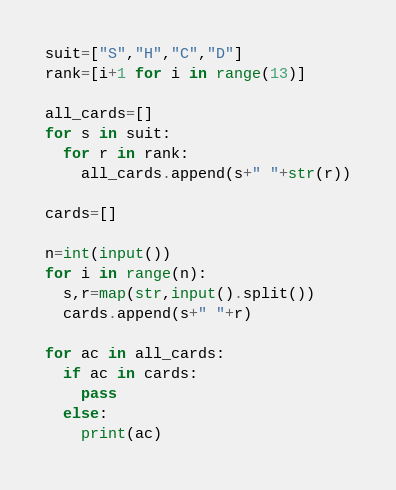Convert code to text. <code><loc_0><loc_0><loc_500><loc_500><_Python_>suit=["S","H","C","D"]
rank=[i+1 for i in range(13)]

all_cards=[]
for s in suit:
  for r in rank:
    all_cards.append(s+" "+str(r))

cards=[]

n=int(input())
for i in range(n):
  s,r=map(str,input().split())
  cards.append(s+" "+r)
  
for ac in all_cards:
  if ac in cards:
    pass
  else:
    print(ac)

</code> 